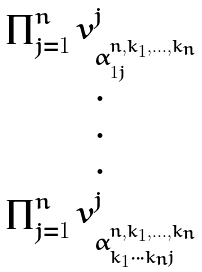Convert formula to latex. <formula><loc_0><loc_0><loc_500><loc_500>\begin{matrix} \prod _ { j = 1 } ^ { n } v _ { \alpha _ { 1 j } ^ { n , k _ { 1 } , \dots , k _ { n } } } ^ { j } \\ \cdot \\ \cdot \\ \cdot \\ \prod _ { j = 1 } ^ { n } v _ { \alpha _ { k _ { 1 } \cdots k _ { n } j } ^ { n , k _ { 1 } , \dots , k _ { n } } } ^ { j } \end{matrix}</formula> 